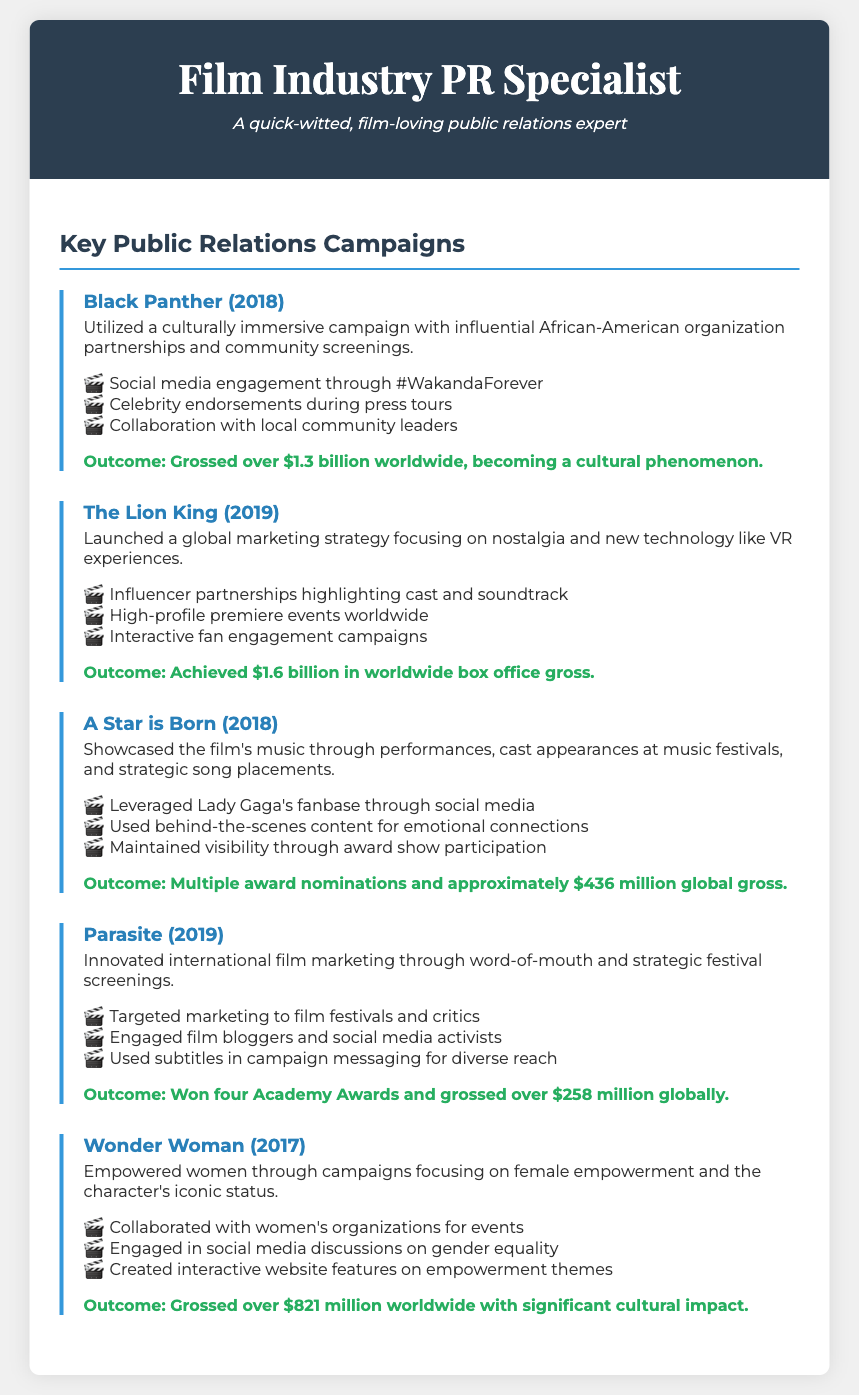what was the box office gross for Black Panther? The box office gross for Black Panther is stated as over $1.3 billion worldwide.
Answer: over $1.3 billion what tactic was used for A Star is Born? The document lists "Leveraged Lady Gaga's fanbase through social media" as a tactic for A Star is Born.
Answer: Leveraged Lady Gaga's fanbase how many Academy Awards did Parasite win? The document states that Parasite won four Academy Awards.
Answer: four which film's campaign focused on nostalgia? The campaign for The Lion King focused on nostalgia as part of its marketing strategy.
Answer: The Lion King what was the outcome of the Wonder Woman campaign? The outcome of the Wonder Woman campaign is summarized as grossing over $821 million worldwide.
Answer: over $821 million name one key element of the campaign for Black Panther. One key element of the campaign for Black Panther was "community screenings."
Answer: community screenings what year was A Star is Born released? The document indicates that A Star is Born was released in 2018.
Answer: 2018 which organizations did Wonder Woman collaborate with? Wonder Woman collaborated with women's organizations for events as part of its campaign.
Answer: women's organizations what social media engagement tactic was used for Black Panther? The tactic used for Black Panther was engagement through the hashtag #WakandaForever.
Answer: #WakandaForever 